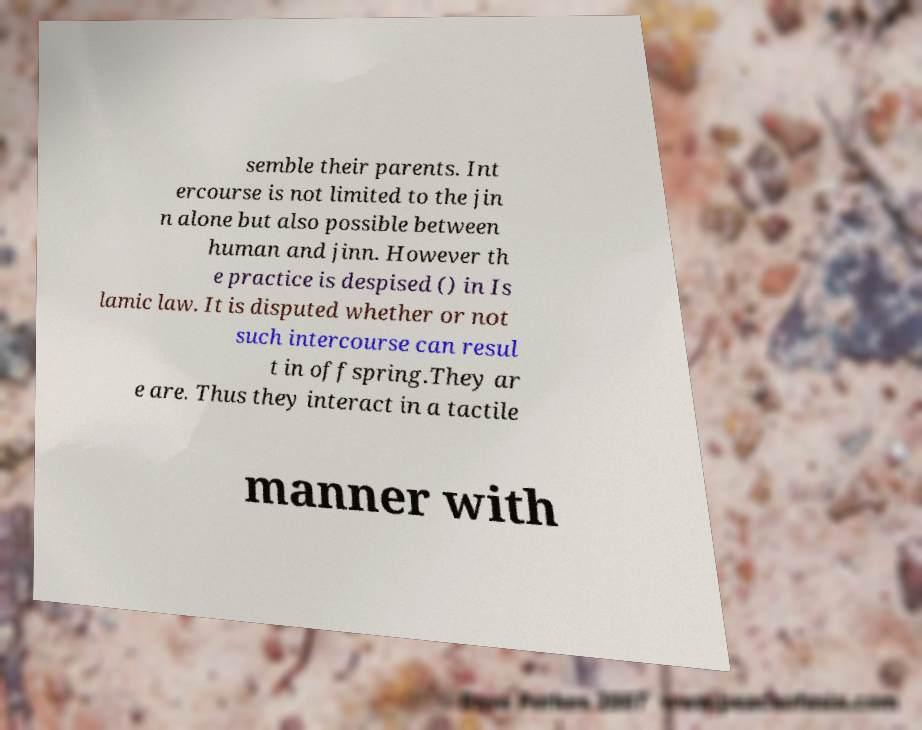Could you extract and type out the text from this image? semble their parents. Int ercourse is not limited to the jin n alone but also possible between human and jinn. However th e practice is despised () in Is lamic law. It is disputed whether or not such intercourse can resul t in offspring.They ar e are. Thus they interact in a tactile manner with 